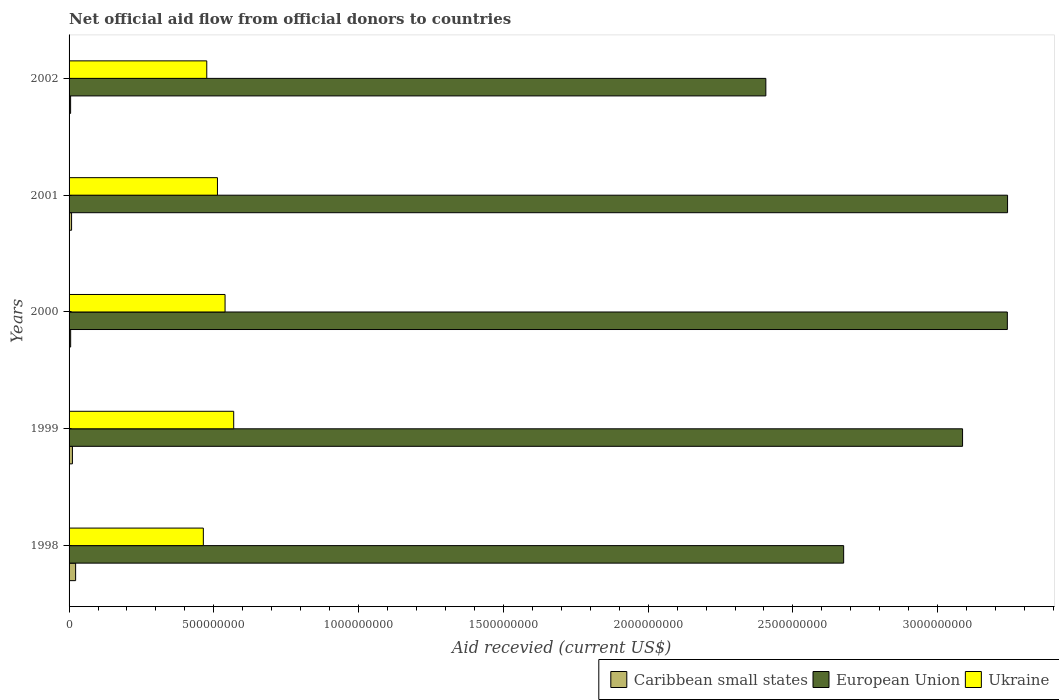Are the number of bars on each tick of the Y-axis equal?
Your response must be concise. Yes. How many bars are there on the 5th tick from the bottom?
Your answer should be very brief. 3. In how many cases, is the number of bars for a given year not equal to the number of legend labels?
Your response must be concise. 0. What is the total aid received in Ukraine in 1999?
Make the answer very short. 5.69e+08. Across all years, what is the maximum total aid received in European Union?
Offer a very short reply. 3.24e+09. Across all years, what is the minimum total aid received in Caribbean small states?
Keep it short and to the point. 5.32e+06. In which year was the total aid received in Ukraine maximum?
Keep it short and to the point. 1999. In which year was the total aid received in Caribbean small states minimum?
Provide a short and direct response. 2002. What is the total total aid received in Ukraine in the graph?
Make the answer very short. 2.56e+09. What is the difference between the total aid received in European Union in 1998 and that in 2002?
Give a very brief answer. 2.69e+08. What is the difference between the total aid received in European Union in 1998 and the total aid received in Caribbean small states in 2001?
Your response must be concise. 2.67e+09. What is the average total aid received in Ukraine per year?
Give a very brief answer. 5.12e+08. In the year 2001, what is the difference between the total aid received in European Union and total aid received in Ukraine?
Provide a succinct answer. 2.73e+09. What is the ratio of the total aid received in Caribbean small states in 1999 to that in 2002?
Ensure brevity in your answer.  2.17. Is the difference between the total aid received in European Union in 1998 and 2001 greater than the difference between the total aid received in Ukraine in 1998 and 2001?
Offer a very short reply. No. What is the difference between the highest and the second highest total aid received in Ukraine?
Provide a short and direct response. 2.98e+07. What is the difference between the highest and the lowest total aid received in European Union?
Keep it short and to the point. 8.35e+08. Is the sum of the total aid received in Ukraine in 1999 and 2000 greater than the maximum total aid received in European Union across all years?
Provide a succinct answer. No. What does the 2nd bar from the top in 2002 represents?
Your response must be concise. European Union. What does the 1st bar from the bottom in 2002 represents?
Offer a terse response. Caribbean small states. Is it the case that in every year, the sum of the total aid received in Caribbean small states and total aid received in European Union is greater than the total aid received in Ukraine?
Your answer should be compact. Yes. How many bars are there?
Provide a short and direct response. 15. How many years are there in the graph?
Provide a succinct answer. 5. Are the values on the major ticks of X-axis written in scientific E-notation?
Offer a very short reply. No. Where does the legend appear in the graph?
Offer a very short reply. Bottom right. How many legend labels are there?
Offer a terse response. 3. How are the legend labels stacked?
Keep it short and to the point. Horizontal. What is the title of the graph?
Your answer should be very brief. Net official aid flow from official donors to countries. Does "Low income" appear as one of the legend labels in the graph?
Provide a succinct answer. No. What is the label or title of the X-axis?
Offer a terse response. Aid recevied (current US$). What is the Aid recevied (current US$) of Caribbean small states in 1998?
Make the answer very short. 2.26e+07. What is the Aid recevied (current US$) of European Union in 1998?
Your response must be concise. 2.68e+09. What is the Aid recevied (current US$) of Ukraine in 1998?
Offer a terse response. 4.64e+08. What is the Aid recevied (current US$) of Caribbean small states in 1999?
Keep it short and to the point. 1.16e+07. What is the Aid recevied (current US$) in European Union in 1999?
Offer a very short reply. 3.09e+09. What is the Aid recevied (current US$) of Ukraine in 1999?
Make the answer very short. 5.69e+08. What is the Aid recevied (current US$) of Caribbean small states in 2000?
Your answer should be very brief. 5.47e+06. What is the Aid recevied (current US$) of European Union in 2000?
Make the answer very short. 3.24e+09. What is the Aid recevied (current US$) of Ukraine in 2000?
Give a very brief answer. 5.39e+08. What is the Aid recevied (current US$) in Caribbean small states in 2001?
Your answer should be very brief. 8.68e+06. What is the Aid recevied (current US$) in European Union in 2001?
Your answer should be very brief. 3.24e+09. What is the Aid recevied (current US$) of Ukraine in 2001?
Provide a succinct answer. 5.12e+08. What is the Aid recevied (current US$) in Caribbean small states in 2002?
Offer a terse response. 5.32e+06. What is the Aid recevied (current US$) in European Union in 2002?
Keep it short and to the point. 2.41e+09. What is the Aid recevied (current US$) of Ukraine in 2002?
Provide a succinct answer. 4.76e+08. Across all years, what is the maximum Aid recevied (current US$) in Caribbean small states?
Give a very brief answer. 2.26e+07. Across all years, what is the maximum Aid recevied (current US$) in European Union?
Give a very brief answer. 3.24e+09. Across all years, what is the maximum Aid recevied (current US$) in Ukraine?
Offer a very short reply. 5.69e+08. Across all years, what is the minimum Aid recevied (current US$) of Caribbean small states?
Offer a very short reply. 5.32e+06. Across all years, what is the minimum Aid recevied (current US$) in European Union?
Make the answer very short. 2.41e+09. Across all years, what is the minimum Aid recevied (current US$) of Ukraine?
Make the answer very short. 4.64e+08. What is the total Aid recevied (current US$) in Caribbean small states in the graph?
Make the answer very short. 5.36e+07. What is the total Aid recevied (current US$) in European Union in the graph?
Provide a succinct answer. 1.46e+1. What is the total Aid recevied (current US$) of Ukraine in the graph?
Your answer should be compact. 2.56e+09. What is the difference between the Aid recevied (current US$) in Caribbean small states in 1998 and that in 1999?
Your answer should be very brief. 1.10e+07. What is the difference between the Aid recevied (current US$) in European Union in 1998 and that in 1999?
Keep it short and to the point. -4.11e+08. What is the difference between the Aid recevied (current US$) of Ukraine in 1998 and that in 1999?
Keep it short and to the point. -1.05e+08. What is the difference between the Aid recevied (current US$) in Caribbean small states in 1998 and that in 2000?
Give a very brief answer. 1.71e+07. What is the difference between the Aid recevied (current US$) in European Union in 1998 and that in 2000?
Your answer should be very brief. -5.65e+08. What is the difference between the Aid recevied (current US$) of Ukraine in 1998 and that in 2000?
Your response must be concise. -7.50e+07. What is the difference between the Aid recevied (current US$) of Caribbean small states in 1998 and that in 2001?
Your response must be concise. 1.39e+07. What is the difference between the Aid recevied (current US$) in European Union in 1998 and that in 2001?
Provide a succinct answer. -5.66e+08. What is the difference between the Aid recevied (current US$) in Ukraine in 1998 and that in 2001?
Offer a very short reply. -4.87e+07. What is the difference between the Aid recevied (current US$) in Caribbean small states in 1998 and that in 2002?
Offer a terse response. 1.73e+07. What is the difference between the Aid recevied (current US$) of European Union in 1998 and that in 2002?
Your response must be concise. 2.69e+08. What is the difference between the Aid recevied (current US$) in Ukraine in 1998 and that in 2002?
Keep it short and to the point. -1.18e+07. What is the difference between the Aid recevied (current US$) in Caribbean small states in 1999 and that in 2000?
Your response must be concise. 6.09e+06. What is the difference between the Aid recevied (current US$) of European Union in 1999 and that in 2000?
Provide a succinct answer. -1.55e+08. What is the difference between the Aid recevied (current US$) of Ukraine in 1999 and that in 2000?
Offer a very short reply. 2.98e+07. What is the difference between the Aid recevied (current US$) of Caribbean small states in 1999 and that in 2001?
Provide a succinct answer. 2.88e+06. What is the difference between the Aid recevied (current US$) of European Union in 1999 and that in 2001?
Your answer should be very brief. -1.55e+08. What is the difference between the Aid recevied (current US$) of Ukraine in 1999 and that in 2001?
Keep it short and to the point. 5.61e+07. What is the difference between the Aid recevied (current US$) in Caribbean small states in 1999 and that in 2002?
Provide a succinct answer. 6.24e+06. What is the difference between the Aid recevied (current US$) of European Union in 1999 and that in 2002?
Offer a very short reply. 6.79e+08. What is the difference between the Aid recevied (current US$) in Ukraine in 1999 and that in 2002?
Provide a short and direct response. 9.30e+07. What is the difference between the Aid recevied (current US$) of Caribbean small states in 2000 and that in 2001?
Ensure brevity in your answer.  -3.21e+06. What is the difference between the Aid recevied (current US$) in European Union in 2000 and that in 2001?
Ensure brevity in your answer.  -7.70e+05. What is the difference between the Aid recevied (current US$) in Ukraine in 2000 and that in 2001?
Offer a very short reply. 2.62e+07. What is the difference between the Aid recevied (current US$) in Caribbean small states in 2000 and that in 2002?
Offer a terse response. 1.50e+05. What is the difference between the Aid recevied (current US$) in European Union in 2000 and that in 2002?
Offer a very short reply. 8.34e+08. What is the difference between the Aid recevied (current US$) in Ukraine in 2000 and that in 2002?
Provide a short and direct response. 6.32e+07. What is the difference between the Aid recevied (current US$) of Caribbean small states in 2001 and that in 2002?
Provide a succinct answer. 3.36e+06. What is the difference between the Aid recevied (current US$) in European Union in 2001 and that in 2002?
Your response must be concise. 8.35e+08. What is the difference between the Aid recevied (current US$) of Ukraine in 2001 and that in 2002?
Your response must be concise. 3.69e+07. What is the difference between the Aid recevied (current US$) of Caribbean small states in 1998 and the Aid recevied (current US$) of European Union in 1999?
Offer a very short reply. -3.06e+09. What is the difference between the Aid recevied (current US$) of Caribbean small states in 1998 and the Aid recevied (current US$) of Ukraine in 1999?
Provide a short and direct response. -5.46e+08. What is the difference between the Aid recevied (current US$) in European Union in 1998 and the Aid recevied (current US$) in Ukraine in 1999?
Provide a succinct answer. 2.11e+09. What is the difference between the Aid recevied (current US$) in Caribbean small states in 1998 and the Aid recevied (current US$) in European Union in 2000?
Provide a short and direct response. -3.22e+09. What is the difference between the Aid recevied (current US$) in Caribbean small states in 1998 and the Aid recevied (current US$) in Ukraine in 2000?
Provide a short and direct response. -5.16e+08. What is the difference between the Aid recevied (current US$) of European Union in 1998 and the Aid recevied (current US$) of Ukraine in 2000?
Offer a very short reply. 2.14e+09. What is the difference between the Aid recevied (current US$) in Caribbean small states in 1998 and the Aid recevied (current US$) in European Union in 2001?
Your answer should be compact. -3.22e+09. What is the difference between the Aid recevied (current US$) in Caribbean small states in 1998 and the Aid recevied (current US$) in Ukraine in 2001?
Ensure brevity in your answer.  -4.90e+08. What is the difference between the Aid recevied (current US$) of European Union in 1998 and the Aid recevied (current US$) of Ukraine in 2001?
Ensure brevity in your answer.  2.16e+09. What is the difference between the Aid recevied (current US$) in Caribbean small states in 1998 and the Aid recevied (current US$) in European Union in 2002?
Offer a very short reply. -2.38e+09. What is the difference between the Aid recevied (current US$) of Caribbean small states in 1998 and the Aid recevied (current US$) of Ukraine in 2002?
Offer a terse response. -4.53e+08. What is the difference between the Aid recevied (current US$) of European Union in 1998 and the Aid recevied (current US$) of Ukraine in 2002?
Provide a succinct answer. 2.20e+09. What is the difference between the Aid recevied (current US$) of Caribbean small states in 1999 and the Aid recevied (current US$) of European Union in 2000?
Your response must be concise. -3.23e+09. What is the difference between the Aid recevied (current US$) in Caribbean small states in 1999 and the Aid recevied (current US$) in Ukraine in 2000?
Your answer should be compact. -5.27e+08. What is the difference between the Aid recevied (current US$) of European Union in 1999 and the Aid recevied (current US$) of Ukraine in 2000?
Offer a terse response. 2.55e+09. What is the difference between the Aid recevied (current US$) of Caribbean small states in 1999 and the Aid recevied (current US$) of European Union in 2001?
Make the answer very short. -3.23e+09. What is the difference between the Aid recevied (current US$) in Caribbean small states in 1999 and the Aid recevied (current US$) in Ukraine in 2001?
Your answer should be compact. -5.01e+08. What is the difference between the Aid recevied (current US$) in European Union in 1999 and the Aid recevied (current US$) in Ukraine in 2001?
Offer a terse response. 2.57e+09. What is the difference between the Aid recevied (current US$) of Caribbean small states in 1999 and the Aid recevied (current US$) of European Union in 2002?
Ensure brevity in your answer.  -2.39e+09. What is the difference between the Aid recevied (current US$) in Caribbean small states in 1999 and the Aid recevied (current US$) in Ukraine in 2002?
Make the answer very short. -4.64e+08. What is the difference between the Aid recevied (current US$) in European Union in 1999 and the Aid recevied (current US$) in Ukraine in 2002?
Offer a very short reply. 2.61e+09. What is the difference between the Aid recevied (current US$) of Caribbean small states in 2000 and the Aid recevied (current US$) of European Union in 2001?
Provide a short and direct response. -3.24e+09. What is the difference between the Aid recevied (current US$) of Caribbean small states in 2000 and the Aid recevied (current US$) of Ukraine in 2001?
Ensure brevity in your answer.  -5.07e+08. What is the difference between the Aid recevied (current US$) in European Union in 2000 and the Aid recevied (current US$) in Ukraine in 2001?
Offer a very short reply. 2.73e+09. What is the difference between the Aid recevied (current US$) in Caribbean small states in 2000 and the Aid recevied (current US$) in European Union in 2002?
Offer a terse response. -2.40e+09. What is the difference between the Aid recevied (current US$) in Caribbean small states in 2000 and the Aid recevied (current US$) in Ukraine in 2002?
Your response must be concise. -4.70e+08. What is the difference between the Aid recevied (current US$) of European Union in 2000 and the Aid recevied (current US$) of Ukraine in 2002?
Offer a very short reply. 2.76e+09. What is the difference between the Aid recevied (current US$) of Caribbean small states in 2001 and the Aid recevied (current US$) of European Union in 2002?
Offer a very short reply. -2.40e+09. What is the difference between the Aid recevied (current US$) of Caribbean small states in 2001 and the Aid recevied (current US$) of Ukraine in 2002?
Keep it short and to the point. -4.67e+08. What is the difference between the Aid recevied (current US$) in European Union in 2001 and the Aid recevied (current US$) in Ukraine in 2002?
Your answer should be very brief. 2.77e+09. What is the average Aid recevied (current US$) in Caribbean small states per year?
Ensure brevity in your answer.  1.07e+07. What is the average Aid recevied (current US$) in European Union per year?
Your answer should be compact. 2.93e+09. What is the average Aid recevied (current US$) of Ukraine per year?
Provide a short and direct response. 5.12e+08. In the year 1998, what is the difference between the Aid recevied (current US$) of Caribbean small states and Aid recevied (current US$) of European Union?
Ensure brevity in your answer.  -2.65e+09. In the year 1998, what is the difference between the Aid recevied (current US$) of Caribbean small states and Aid recevied (current US$) of Ukraine?
Provide a succinct answer. -4.41e+08. In the year 1998, what is the difference between the Aid recevied (current US$) of European Union and Aid recevied (current US$) of Ukraine?
Your answer should be very brief. 2.21e+09. In the year 1999, what is the difference between the Aid recevied (current US$) in Caribbean small states and Aid recevied (current US$) in European Union?
Your answer should be compact. -3.07e+09. In the year 1999, what is the difference between the Aid recevied (current US$) of Caribbean small states and Aid recevied (current US$) of Ukraine?
Your answer should be very brief. -5.57e+08. In the year 1999, what is the difference between the Aid recevied (current US$) of European Union and Aid recevied (current US$) of Ukraine?
Your answer should be very brief. 2.52e+09. In the year 2000, what is the difference between the Aid recevied (current US$) of Caribbean small states and Aid recevied (current US$) of European Union?
Make the answer very short. -3.24e+09. In the year 2000, what is the difference between the Aid recevied (current US$) of Caribbean small states and Aid recevied (current US$) of Ukraine?
Give a very brief answer. -5.33e+08. In the year 2000, what is the difference between the Aid recevied (current US$) in European Union and Aid recevied (current US$) in Ukraine?
Your answer should be compact. 2.70e+09. In the year 2001, what is the difference between the Aid recevied (current US$) in Caribbean small states and Aid recevied (current US$) in European Union?
Your answer should be compact. -3.23e+09. In the year 2001, what is the difference between the Aid recevied (current US$) of Caribbean small states and Aid recevied (current US$) of Ukraine?
Provide a short and direct response. -5.04e+08. In the year 2001, what is the difference between the Aid recevied (current US$) of European Union and Aid recevied (current US$) of Ukraine?
Offer a very short reply. 2.73e+09. In the year 2002, what is the difference between the Aid recevied (current US$) of Caribbean small states and Aid recevied (current US$) of European Union?
Keep it short and to the point. -2.40e+09. In the year 2002, what is the difference between the Aid recevied (current US$) in Caribbean small states and Aid recevied (current US$) in Ukraine?
Keep it short and to the point. -4.70e+08. In the year 2002, what is the difference between the Aid recevied (current US$) in European Union and Aid recevied (current US$) in Ukraine?
Your response must be concise. 1.93e+09. What is the ratio of the Aid recevied (current US$) in Caribbean small states in 1998 to that in 1999?
Your answer should be compact. 1.96. What is the ratio of the Aid recevied (current US$) of European Union in 1998 to that in 1999?
Make the answer very short. 0.87. What is the ratio of the Aid recevied (current US$) of Ukraine in 1998 to that in 1999?
Your answer should be very brief. 0.82. What is the ratio of the Aid recevied (current US$) in Caribbean small states in 1998 to that in 2000?
Your answer should be compact. 4.13. What is the ratio of the Aid recevied (current US$) in European Union in 1998 to that in 2000?
Offer a terse response. 0.83. What is the ratio of the Aid recevied (current US$) in Ukraine in 1998 to that in 2000?
Keep it short and to the point. 0.86. What is the ratio of the Aid recevied (current US$) in Caribbean small states in 1998 to that in 2001?
Make the answer very short. 2.6. What is the ratio of the Aid recevied (current US$) in European Union in 1998 to that in 2001?
Your answer should be compact. 0.83. What is the ratio of the Aid recevied (current US$) of Ukraine in 1998 to that in 2001?
Make the answer very short. 0.91. What is the ratio of the Aid recevied (current US$) in Caribbean small states in 1998 to that in 2002?
Keep it short and to the point. 4.25. What is the ratio of the Aid recevied (current US$) of European Union in 1998 to that in 2002?
Your response must be concise. 1.11. What is the ratio of the Aid recevied (current US$) in Ukraine in 1998 to that in 2002?
Offer a terse response. 0.98. What is the ratio of the Aid recevied (current US$) in Caribbean small states in 1999 to that in 2000?
Provide a short and direct response. 2.11. What is the ratio of the Aid recevied (current US$) of European Union in 1999 to that in 2000?
Give a very brief answer. 0.95. What is the ratio of the Aid recevied (current US$) of Ukraine in 1999 to that in 2000?
Your response must be concise. 1.06. What is the ratio of the Aid recevied (current US$) of Caribbean small states in 1999 to that in 2001?
Keep it short and to the point. 1.33. What is the ratio of the Aid recevied (current US$) in Ukraine in 1999 to that in 2001?
Provide a succinct answer. 1.11. What is the ratio of the Aid recevied (current US$) in Caribbean small states in 1999 to that in 2002?
Your answer should be very brief. 2.17. What is the ratio of the Aid recevied (current US$) of European Union in 1999 to that in 2002?
Ensure brevity in your answer.  1.28. What is the ratio of the Aid recevied (current US$) of Ukraine in 1999 to that in 2002?
Make the answer very short. 1.2. What is the ratio of the Aid recevied (current US$) in Caribbean small states in 2000 to that in 2001?
Provide a short and direct response. 0.63. What is the ratio of the Aid recevied (current US$) in Ukraine in 2000 to that in 2001?
Give a very brief answer. 1.05. What is the ratio of the Aid recevied (current US$) of Caribbean small states in 2000 to that in 2002?
Ensure brevity in your answer.  1.03. What is the ratio of the Aid recevied (current US$) in European Union in 2000 to that in 2002?
Ensure brevity in your answer.  1.35. What is the ratio of the Aid recevied (current US$) in Ukraine in 2000 to that in 2002?
Ensure brevity in your answer.  1.13. What is the ratio of the Aid recevied (current US$) in Caribbean small states in 2001 to that in 2002?
Provide a short and direct response. 1.63. What is the ratio of the Aid recevied (current US$) of European Union in 2001 to that in 2002?
Keep it short and to the point. 1.35. What is the ratio of the Aid recevied (current US$) in Ukraine in 2001 to that in 2002?
Make the answer very short. 1.08. What is the difference between the highest and the second highest Aid recevied (current US$) in Caribbean small states?
Provide a short and direct response. 1.10e+07. What is the difference between the highest and the second highest Aid recevied (current US$) of European Union?
Your answer should be compact. 7.70e+05. What is the difference between the highest and the second highest Aid recevied (current US$) in Ukraine?
Your answer should be very brief. 2.98e+07. What is the difference between the highest and the lowest Aid recevied (current US$) of Caribbean small states?
Provide a short and direct response. 1.73e+07. What is the difference between the highest and the lowest Aid recevied (current US$) in European Union?
Give a very brief answer. 8.35e+08. What is the difference between the highest and the lowest Aid recevied (current US$) of Ukraine?
Your answer should be compact. 1.05e+08. 